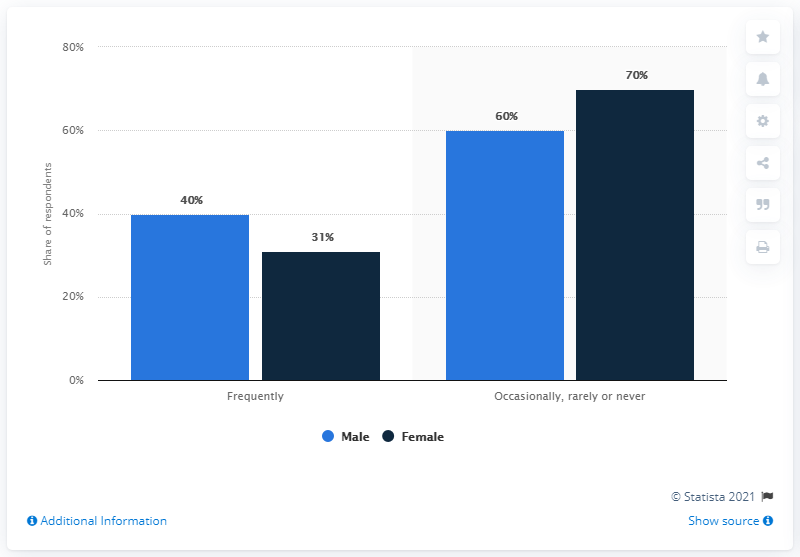Draw attention to some important aspects in this diagram. The option that has a difference of 10% between male and female is rarely or never. The total percentage of males is 100%. 